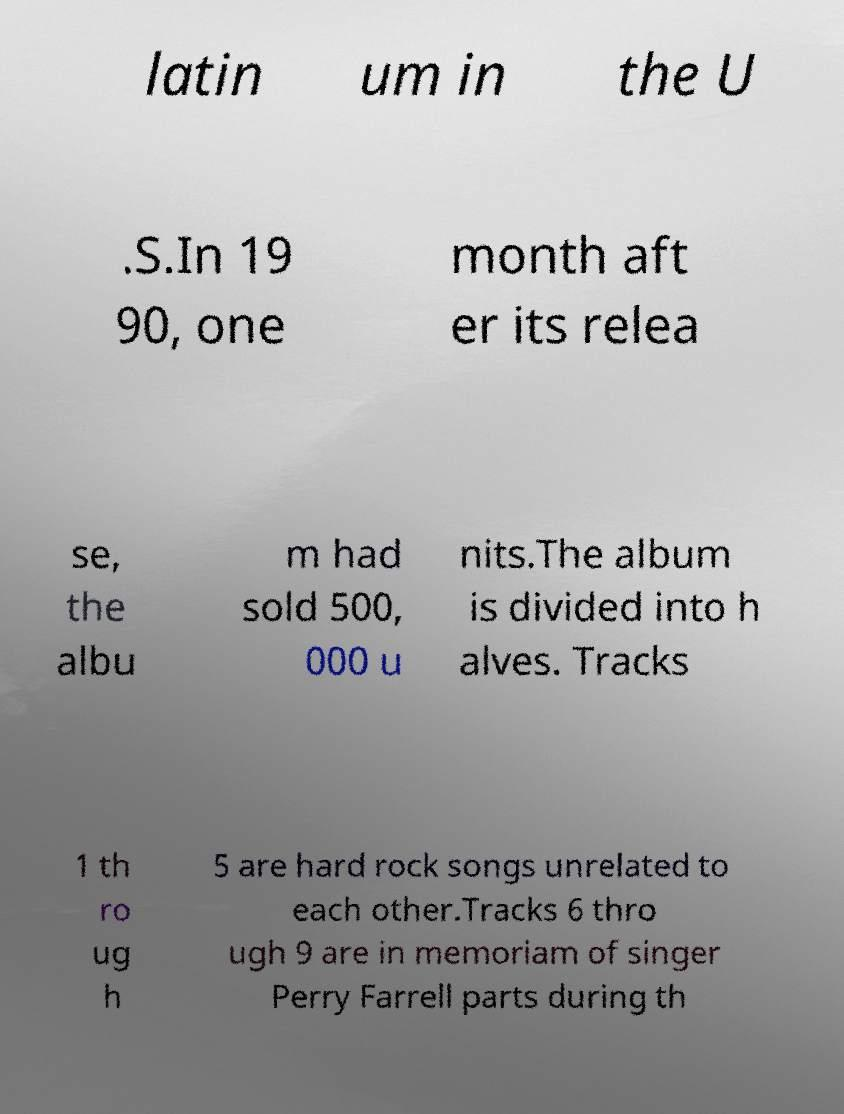For documentation purposes, I need the text within this image transcribed. Could you provide that? latin um in the U .S.In 19 90, one month aft er its relea se, the albu m had sold 500, 000 u nits.The album is divided into h alves. Tracks 1 th ro ug h 5 are hard rock songs unrelated to each other.Tracks 6 thro ugh 9 are in memoriam of singer Perry Farrell parts during th 